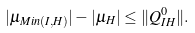Convert formula to latex. <formula><loc_0><loc_0><loc_500><loc_500>| \mu _ { M i n ( I , H ) } | - | \mu _ { H } | \leq \| Q ^ { 0 } _ { I H } \| .</formula> 